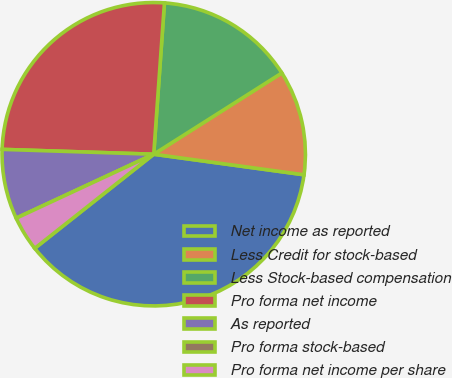Convert chart to OTSL. <chart><loc_0><loc_0><loc_500><loc_500><pie_chart><fcel>Net income as reported<fcel>Less Credit for stock-based<fcel>Less Stock-based compensation<fcel>Pro forma net income<fcel>As reported<fcel>Pro forma stock-based<fcel>Pro forma net income per share<nl><fcel>37.19%<fcel>11.16%<fcel>14.88%<fcel>25.62%<fcel>7.44%<fcel>0.0%<fcel>3.72%<nl></chart> 